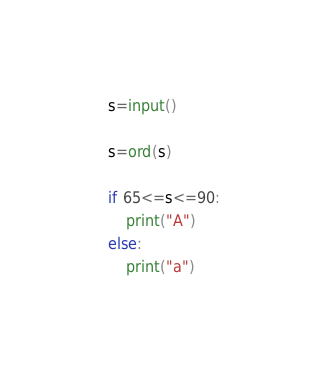<code> <loc_0><loc_0><loc_500><loc_500><_Python_>s=input()

s=ord(s)

if 65<=s<=90:
    print("A")
else:
    print("a")
</code> 